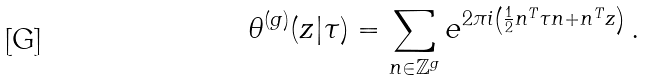<formula> <loc_0><loc_0><loc_500><loc_500>\theta ^ { ( g ) } ( z | \tau ) = \sum _ { n \in \mathbb { Z } ^ { g } } e ^ { 2 \pi i \left ( \frac { 1 } { 2 } n ^ { T } \tau n + n ^ { T } z \right ) } \, .</formula> 